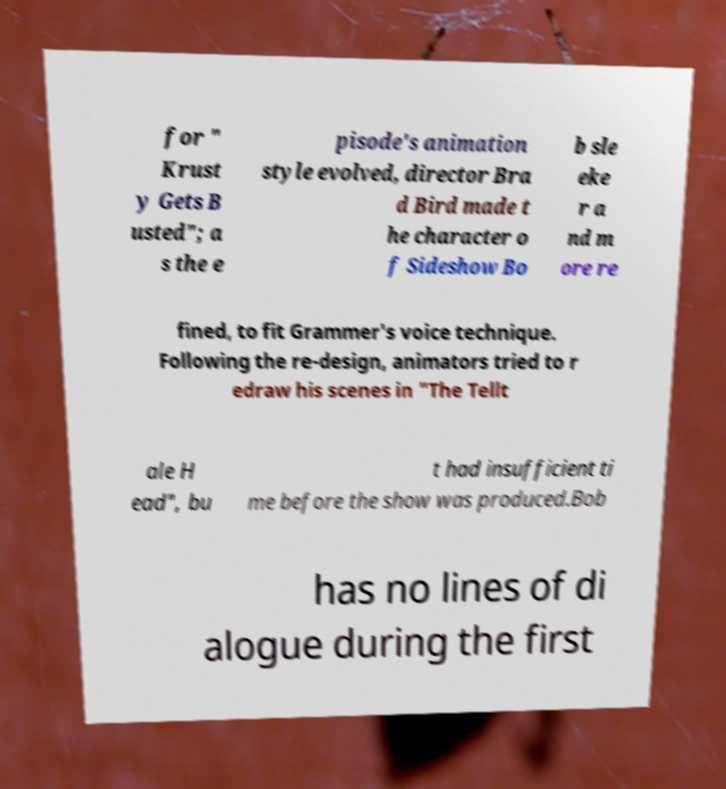Please identify and transcribe the text found in this image. for " Krust y Gets B usted"; a s the e pisode's animation style evolved, director Bra d Bird made t he character o f Sideshow Bo b sle eke r a nd m ore re fined, to fit Grammer's voice technique. Following the re-design, animators tried to r edraw his scenes in "The Tellt ale H ead", bu t had insufficient ti me before the show was produced.Bob has no lines of di alogue during the first 